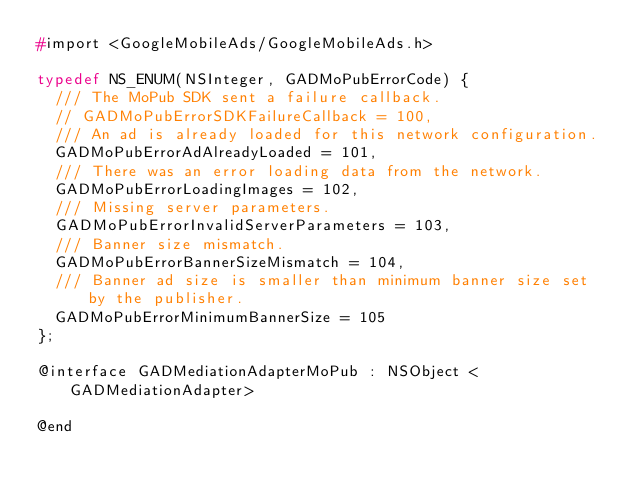<code> <loc_0><loc_0><loc_500><loc_500><_C_>#import <GoogleMobileAds/GoogleMobileAds.h>

typedef NS_ENUM(NSInteger, GADMoPubErrorCode) {
  /// The MoPub SDK sent a failure callback.
  // GADMoPubErrorSDKFailureCallback = 100,
  /// An ad is already loaded for this network configuration.
  GADMoPubErrorAdAlreadyLoaded = 101,
  /// There was an error loading data from the network.
  GADMoPubErrorLoadingImages = 102,
  /// Missing server parameters.
  GADMoPubErrorInvalidServerParameters = 103,
  /// Banner size mismatch.
  GADMoPubErrorBannerSizeMismatch = 104,
  /// Banner ad size is smaller than minimum banner size set by the publisher.
  GADMoPubErrorMinimumBannerSize = 105
};

@interface GADMediationAdapterMoPub : NSObject <GADMediationAdapter>

@end
</code> 